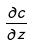Convert formula to latex. <formula><loc_0><loc_0><loc_500><loc_500>\frac { \partial c } { \partial z }</formula> 